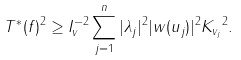<formula> <loc_0><loc_0><loc_500><loc_500>\| T ^ { \ast } ( f ) \| ^ { 2 } \geq I _ { v } ^ { - 2 } \sum _ { j = 1 } ^ { n } | \lambda _ { j } | ^ { 2 } | w ( u _ { j } ) | ^ { 2 } \| K _ { v _ { j } } \| ^ { 2 } .</formula> 